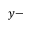<formula> <loc_0><loc_0><loc_500><loc_500>y -</formula> 